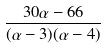Convert formula to latex. <formula><loc_0><loc_0><loc_500><loc_500>\frac { 3 0 \alpha - 6 6 } { ( \alpha - 3 ) ( \alpha - 4 ) }</formula> 